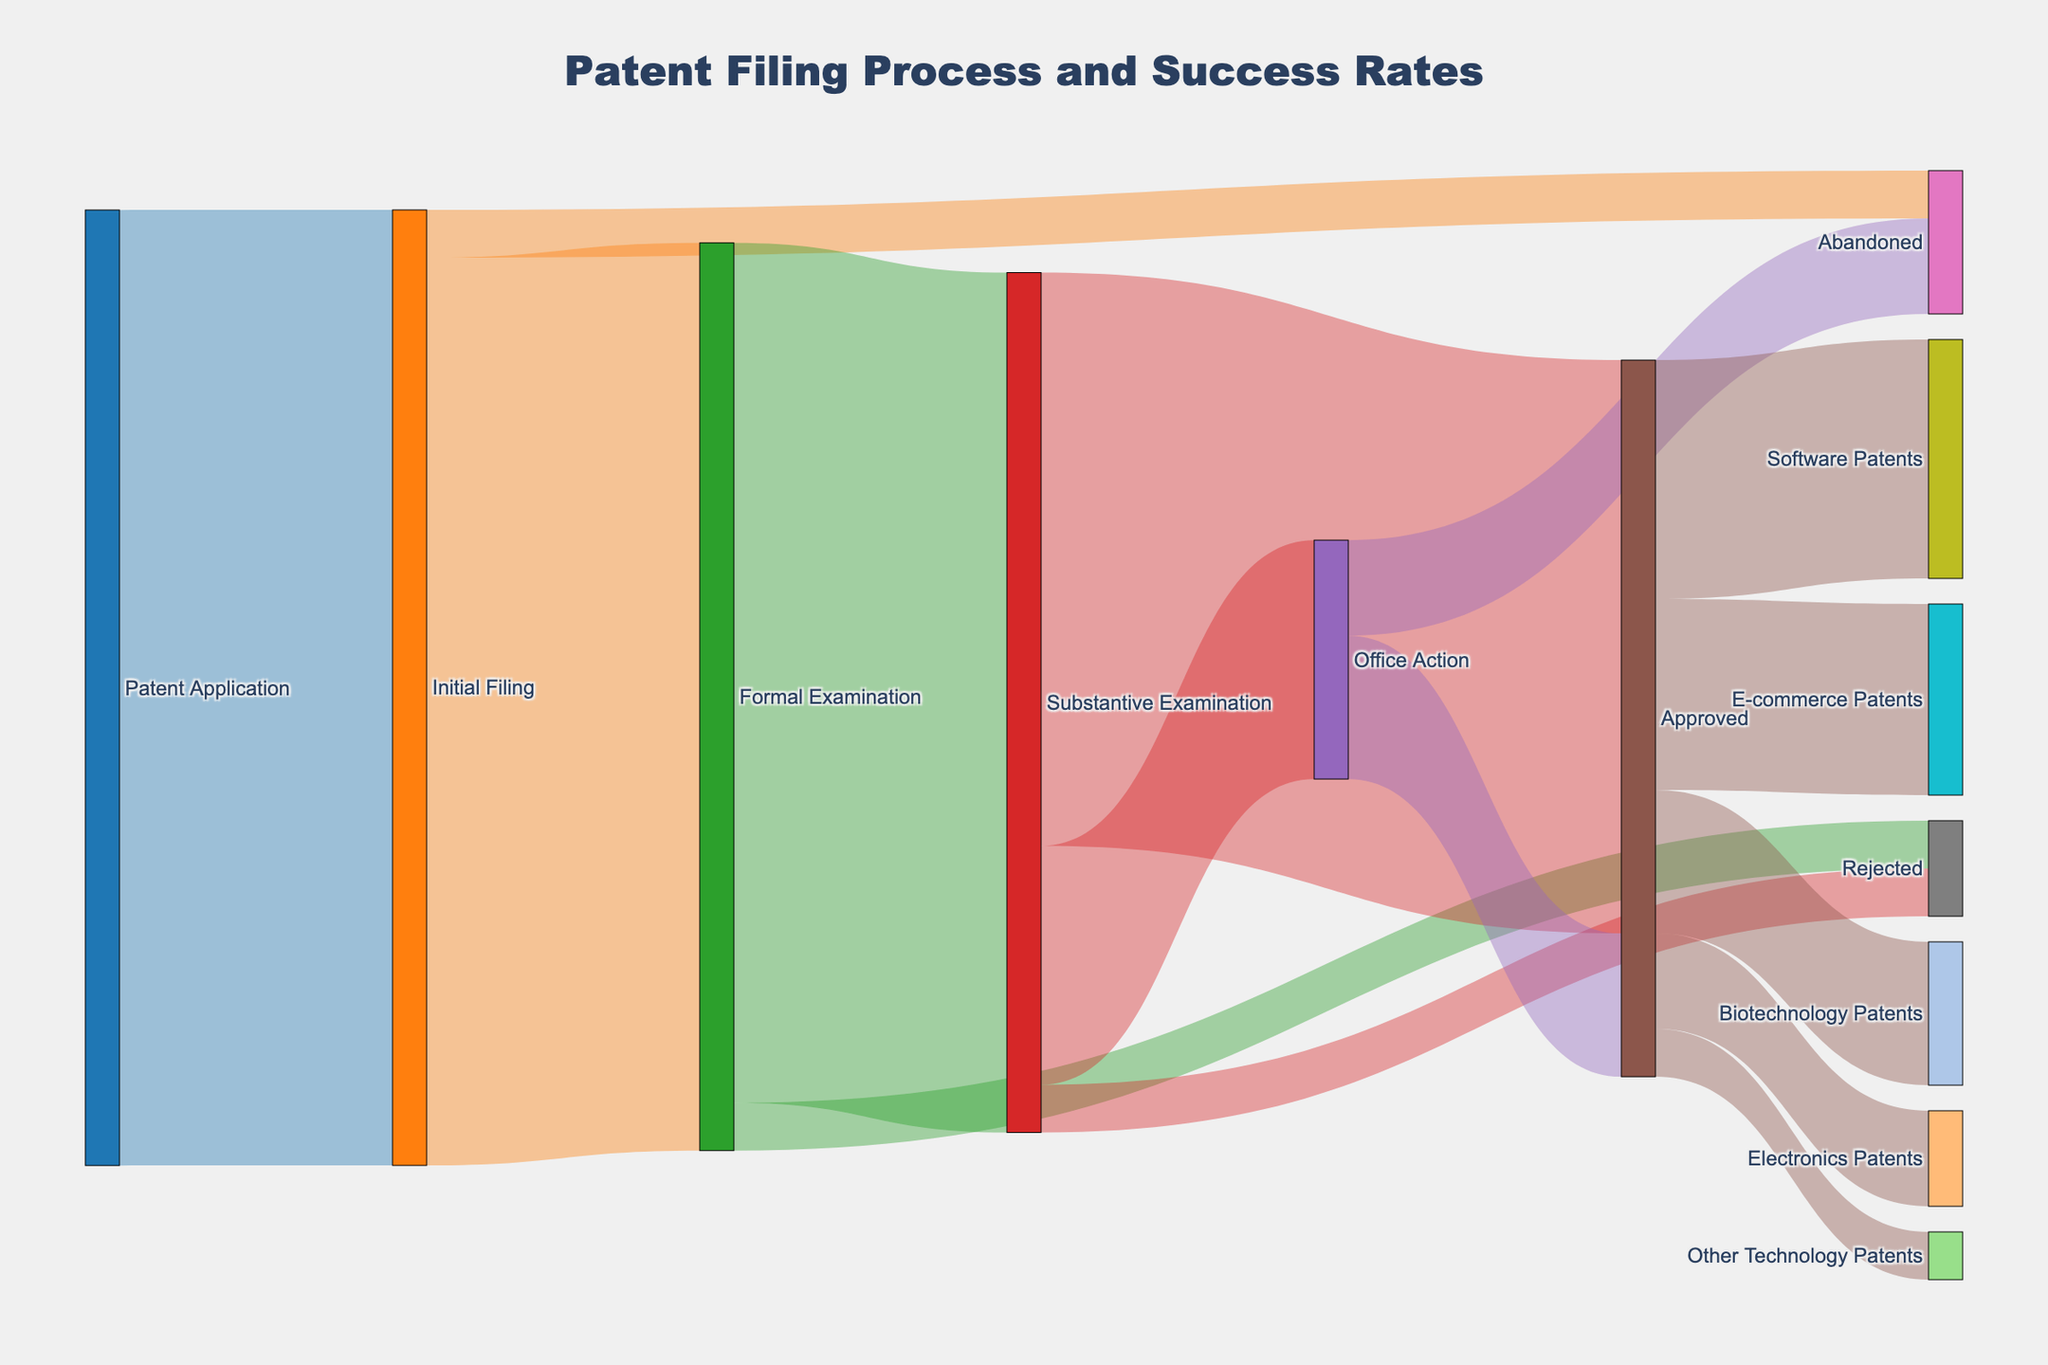What is the title of the Sankey Diagram? The title can be found at the top of the diagram and it provides an overview of what the diagram represents. The title is "Patent Filing Process and Success Rates."
Answer: Patent Filing Process and Success Rates Which step has the highest number of initial filings? We need to look at the paths leading from "Patent Application" to other nodes. The path to "Initial Filing" has the highest number, which is 1000.
Answer: Initial Filing How many patents were abandoned after the Office Action? To determine this, we follow the path from "Office Action" to "Abandoned." The value associated with this transition is given in the data table as 100.
Answer: 100 Which sector received the most approved patents? We need to follow the "Approved" node and compare the values going to each sector. The highest value from "Approved" goes to "Software Patents" with 250.
Answer: Software Patents What is the total number of patents that reached the Substantive Examination stage? We add the number of patents from "Formal Examination" to "Substantive Examination" and subtract any that were rejected along the way. From the data, 900 reach the Substantive Examination directly, so the total is 900.
Answer: 900 How many patents were approved after the Substantive Examination stage? Check the paths leading from "Substantive Examination" to "Approved." The value is 600.
Answer: 600 How many patents were abandoned before reaching any examination stage? This includes patents abandoned at "Initial Filing" and those from "Office Action." We add 50 (from Initial Filing to Abandoned) and 100 (from Office Action to Abandoned). The result is 150.
Answer: 150 What is the combined total of approved patents across all technology sectors? Sum the values of all the nodes receiving patents from "Approved": 250 (Software) + 200 (E-commerce) + 150 (Biotechnology) + 100 (Electronics) + 50 (Other Technology). The total is 750.
Answer: 750 Compare the number of patents rejected during Formal Examination to those rejected during Substantive Examination. Which stage has more rejections? Look at the paths from "Formal Examination" to "Rejected" and from "Substantive Examination" to "Rejected." 50 patents are rejected at each stage, so they are equal.
Answer: Equal Of the patents approved after an Office Action, how many are within E-commerce and Biotechnology sectors combined? Follow the "Approved" node and see the paths leading to "E-commerce Patents" and "Biotechnology Patents." Add their values: 200 (E-commerce) + 150 (Biotechnology). The total is 350.
Answer: 350 